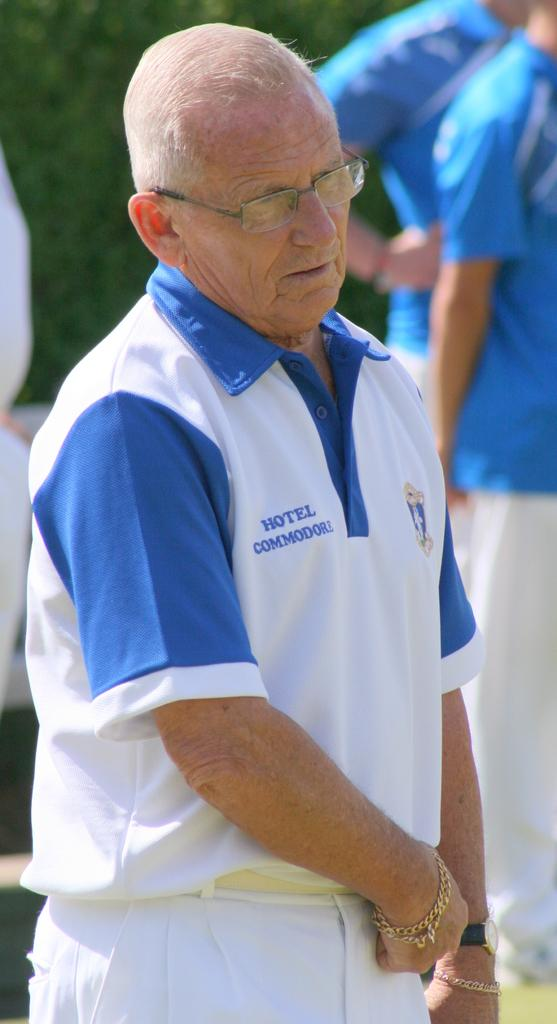<image>
Relay a brief, clear account of the picture shown. the word hotel is on the shirt of a person 